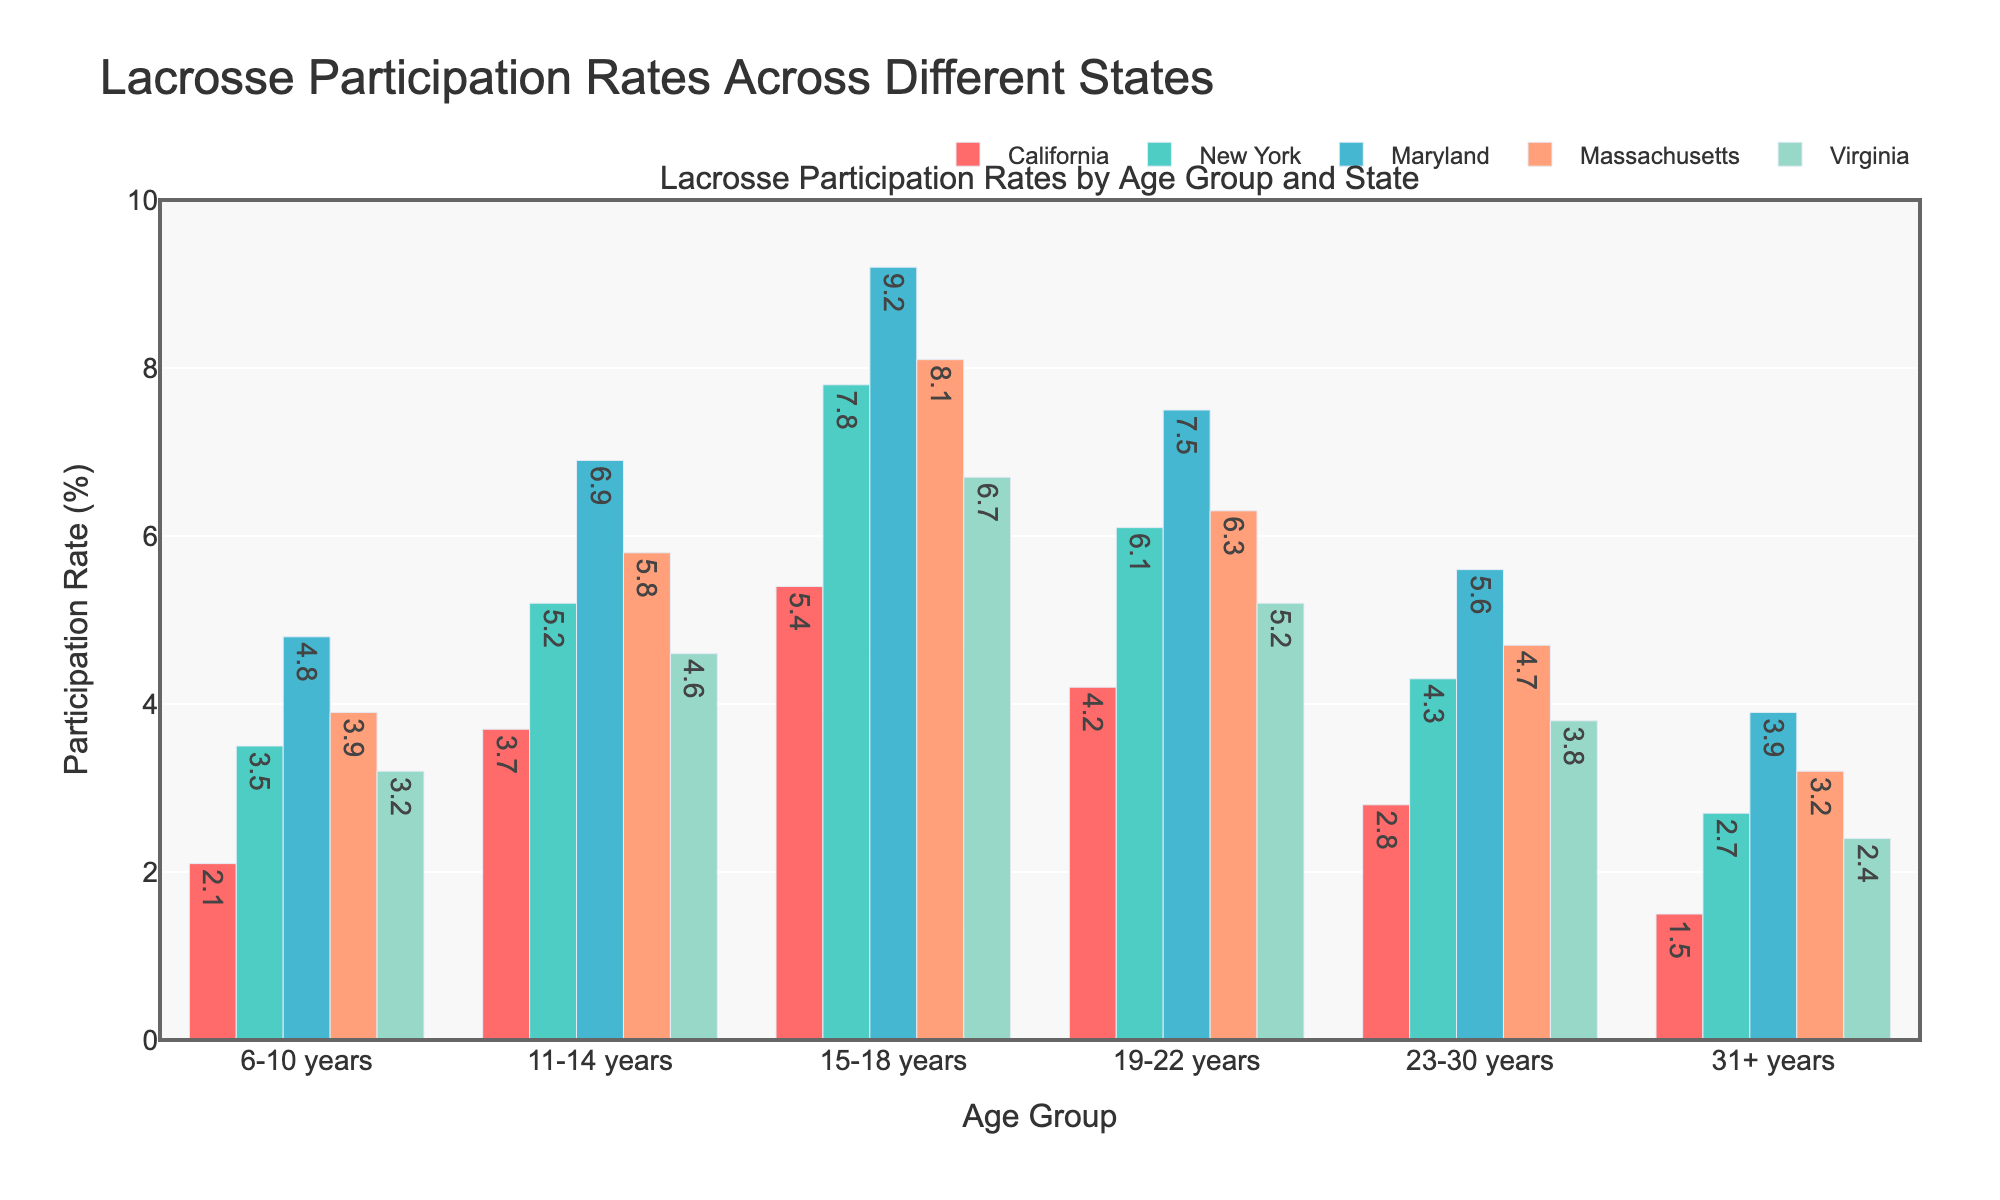Which state has the highest lacrosse participation rate for the 6-10 years age group? By comparing the bars representing the 6-10 years age group across all states, the tallest bar represents Maryland, indicating it has the highest participation rate.
Answer: Maryland Which age group has the highest participation rate in California? By comparing the heights of the bars for all age groups within California, the tallest bar represents the 15-18 years age group.
Answer: 15-18 years What is the total lacrosse participation rate for individuals aged 19-30 years across all states combined? First, add the participation rates of the 19-22 years age group across all states: 4.2 (CA) + 6.1 (NY) + 7.5 (MD) + 6.3 (MA) + 5.2 (VA) = 29.3. Then, add the participation rates of the 23-30 years age group across all states: 2.8 (CA) + 4.3 (NY) + 5.6 (MD) + 4.7 (MA) + 3.8 (VA) = 21.2. Finally, sum these two totals: 29.3 + 21.2 = 50.5.
Answer: 50.5 Which state shows the most decrease in participation rate from the 15-18 years age group to the 19-22 years age group? By calculating the differences in participation rates between the 15-18 years and 19-22 years groups for each state: CA (5.4 - 4.2 = 1.2), NY (7.8 - 6.1 = 1.7), MD (9.2 - 7.5 = 1.7), MA (8.1 - 6.3 = 1.8), VA (6.7 - 5.2 = 1.5). Massachusetts has the largest decrease of 1.8.
Answer: Massachusetts In which age group does New York have its highest lacrosse participation rate? By comparing the heights of the bars for all age groups within New York, the tallest bar represents the 15-18 years age group.
Answer: 15-18 years How does the average participation rate of the 11-14 years age group compare to that of the 31+ years age group across all states? First, calculate the average participation rate for the 11-14 years age group: (3.7 + 5.2 + 6.9 + 5.8 + 4.6) / 5 = 5.24. Then, calculate the average participation rate for the 31+ years age group: (1.5 + 2.7 + 3.9 + 3.2 + 2.4) / 5 = 2.74. Finally, compare the two averages: 5.24 is higher than 2.74.
Answer: 11-14 years has a higher rate Which age group in Virginia has the highest participation rate? By comparing the heights of the bars for all age groups within Virginia, the tallest bar represents the 15-18 years age group.
Answer: 15-18 years Is there any state where the participation rate consistently decreases with increasing age groups? To determine if there is a state with a consistently decreasing participation rate with increasing age groups, check if each successive age group's bar decreases in height compared to the previous one. None of the states follow a consistently decreasing pattern.
Answer: No What is the average lacrosse participation rate for Massachusetts across all age groups? Calculate the sum of the participation rates for each age group in Massachusetts: 3.9 + 5.8 + 8.1 + 6.3 + 4.7 + 3.2 = 32.0. Then, divide by the number of age groups (6): 32.0 / 6 = 5.33.
Answer: 5.33 For which age group does Maryland have the largest margin over the other states? By comparing the differences in Maryland's participation rate compared to the other states for each age group, the 15-18 years age group shows the largest margin. Maryland's rate is 9.2, and the next highest in this category is New York at 7.8, giving a margin of 9.2 - 7.8 = 1.4. This margin is largest compared to other age groups' margins.
Answer: 15-18 years 